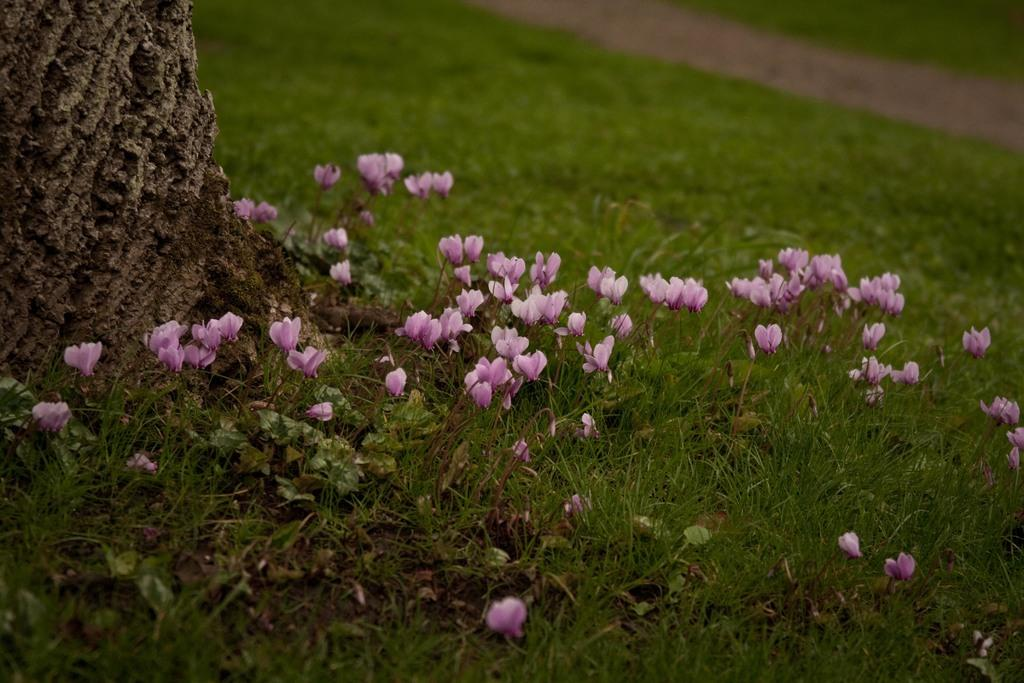What type of vegetation can be seen in the image? There is grass and plants with flowers in the image. Is there any indication of a path or walkway in the image? Yes, there is a path in the grassland. What can be seen on the left side of the image? There is a tree trunk on the left side of the image. What is the aftermath of the partner's decision in the image? There is no partner or decision-making process depicted in the image; it features a grassland with plants, a path, and a tree trunk. 